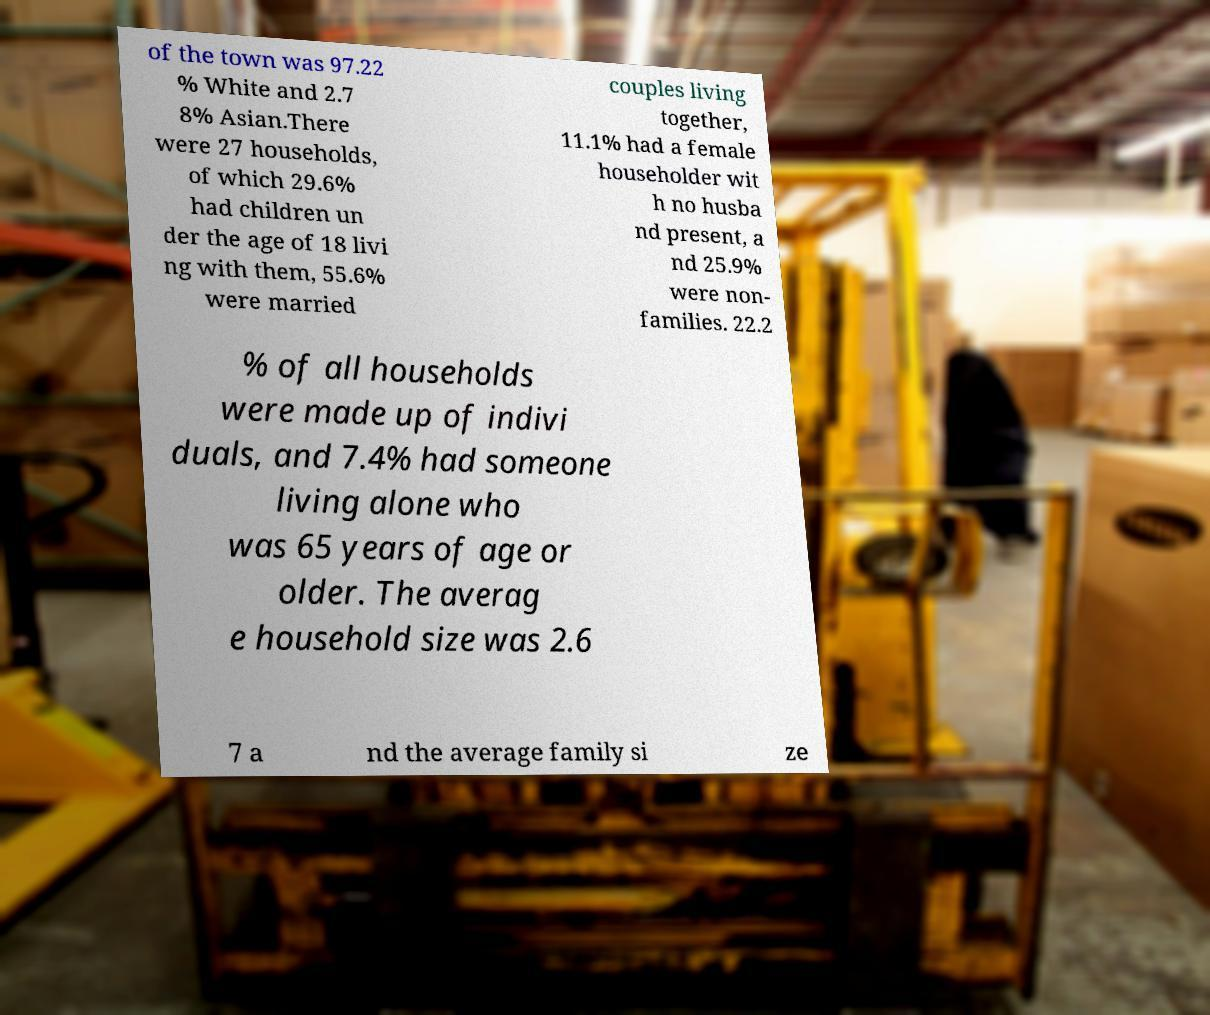There's text embedded in this image that I need extracted. Can you transcribe it verbatim? of the town was 97.22 % White and 2.7 8% Asian.There were 27 households, of which 29.6% had children un der the age of 18 livi ng with them, 55.6% were married couples living together, 11.1% had a female householder wit h no husba nd present, a nd 25.9% were non- families. 22.2 % of all households were made up of indivi duals, and 7.4% had someone living alone who was 65 years of age or older. The averag e household size was 2.6 7 a nd the average family si ze 